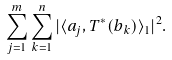<formula> <loc_0><loc_0><loc_500><loc_500>\sum _ { j = 1 } ^ { m } \sum _ { k = 1 } ^ { n } | \langle a _ { j } , T ^ { * } ( b _ { k } ) \rangle _ { 1 } | ^ { 2 } .</formula> 